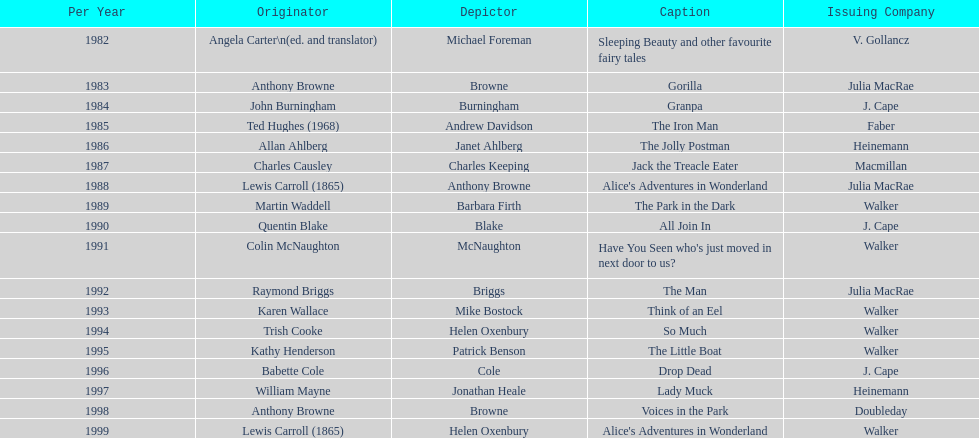Which title was after the year 1991 but before the year 1993? The Man. 